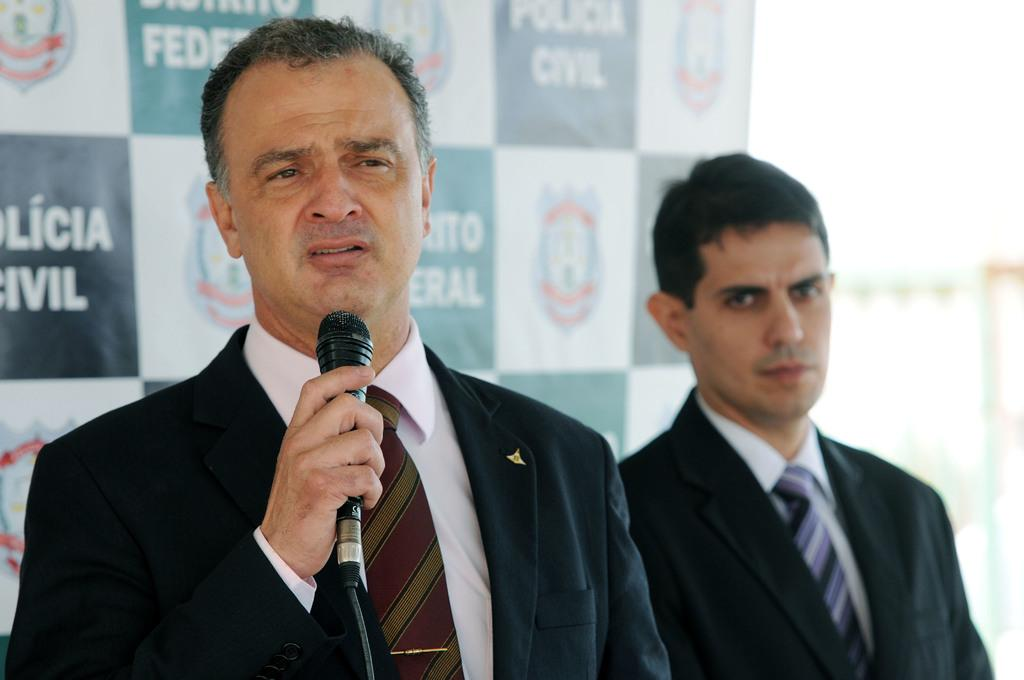What is the man in the image wearing? The man is wearing a black suit in the image. What is the man holding in his hand? The man is holding a mic in his hand. Can you describe the person standing next to the man? There is another person standing to the right side of the man. What can be seen in the background of the image? A poster is visible in the background of the image. How many jars of honey are on the table in the image? There is no table or jars of honey present in the image. What type of girls are visible in the image? There are no girls visible in the image. 